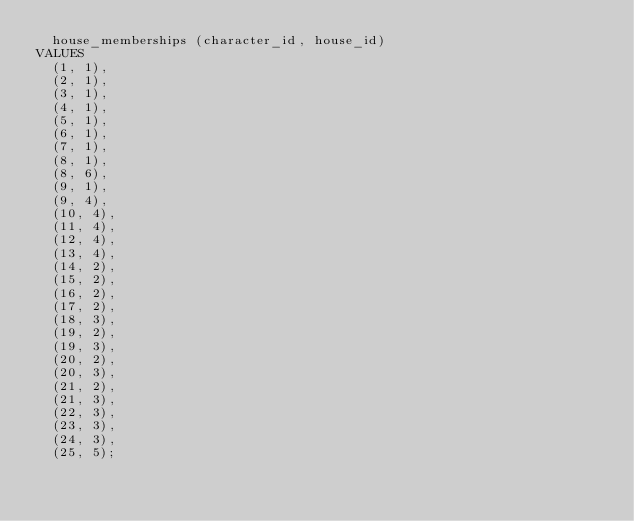Convert code to text. <code><loc_0><loc_0><loc_500><loc_500><_SQL_>  house_memberships (character_id, house_id)
VALUES
  (1, 1),
  (2, 1),
  (3, 1),
  (4, 1),
  (5, 1),
  (6, 1),
  (7, 1),
  (8, 1),
  (8, 6),
  (9, 1),
  (9, 4),
  (10, 4),
  (11, 4),
  (12, 4),
  (13, 4),
  (14, 2),
  (15, 2),
  (16, 2),
  (17, 2),
  (18, 3),
  (19, 2),
  (19, 3),
  (20, 2),
  (20, 3),
  (21, 2),
  (21, 3),
  (22, 3),
  (23, 3),
  (24, 3),
  (25, 5);
</code> 